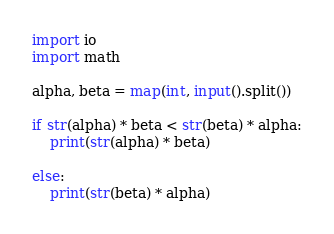Convert code to text. <code><loc_0><loc_0><loc_500><loc_500><_Python_>import io
import math

alpha, beta = map(int, input().split())
 
if str(alpha) * beta < str(beta) * alpha:
    print(str(alpha) * beta)
    
else:
    print(str(beta) * alpha)</code> 